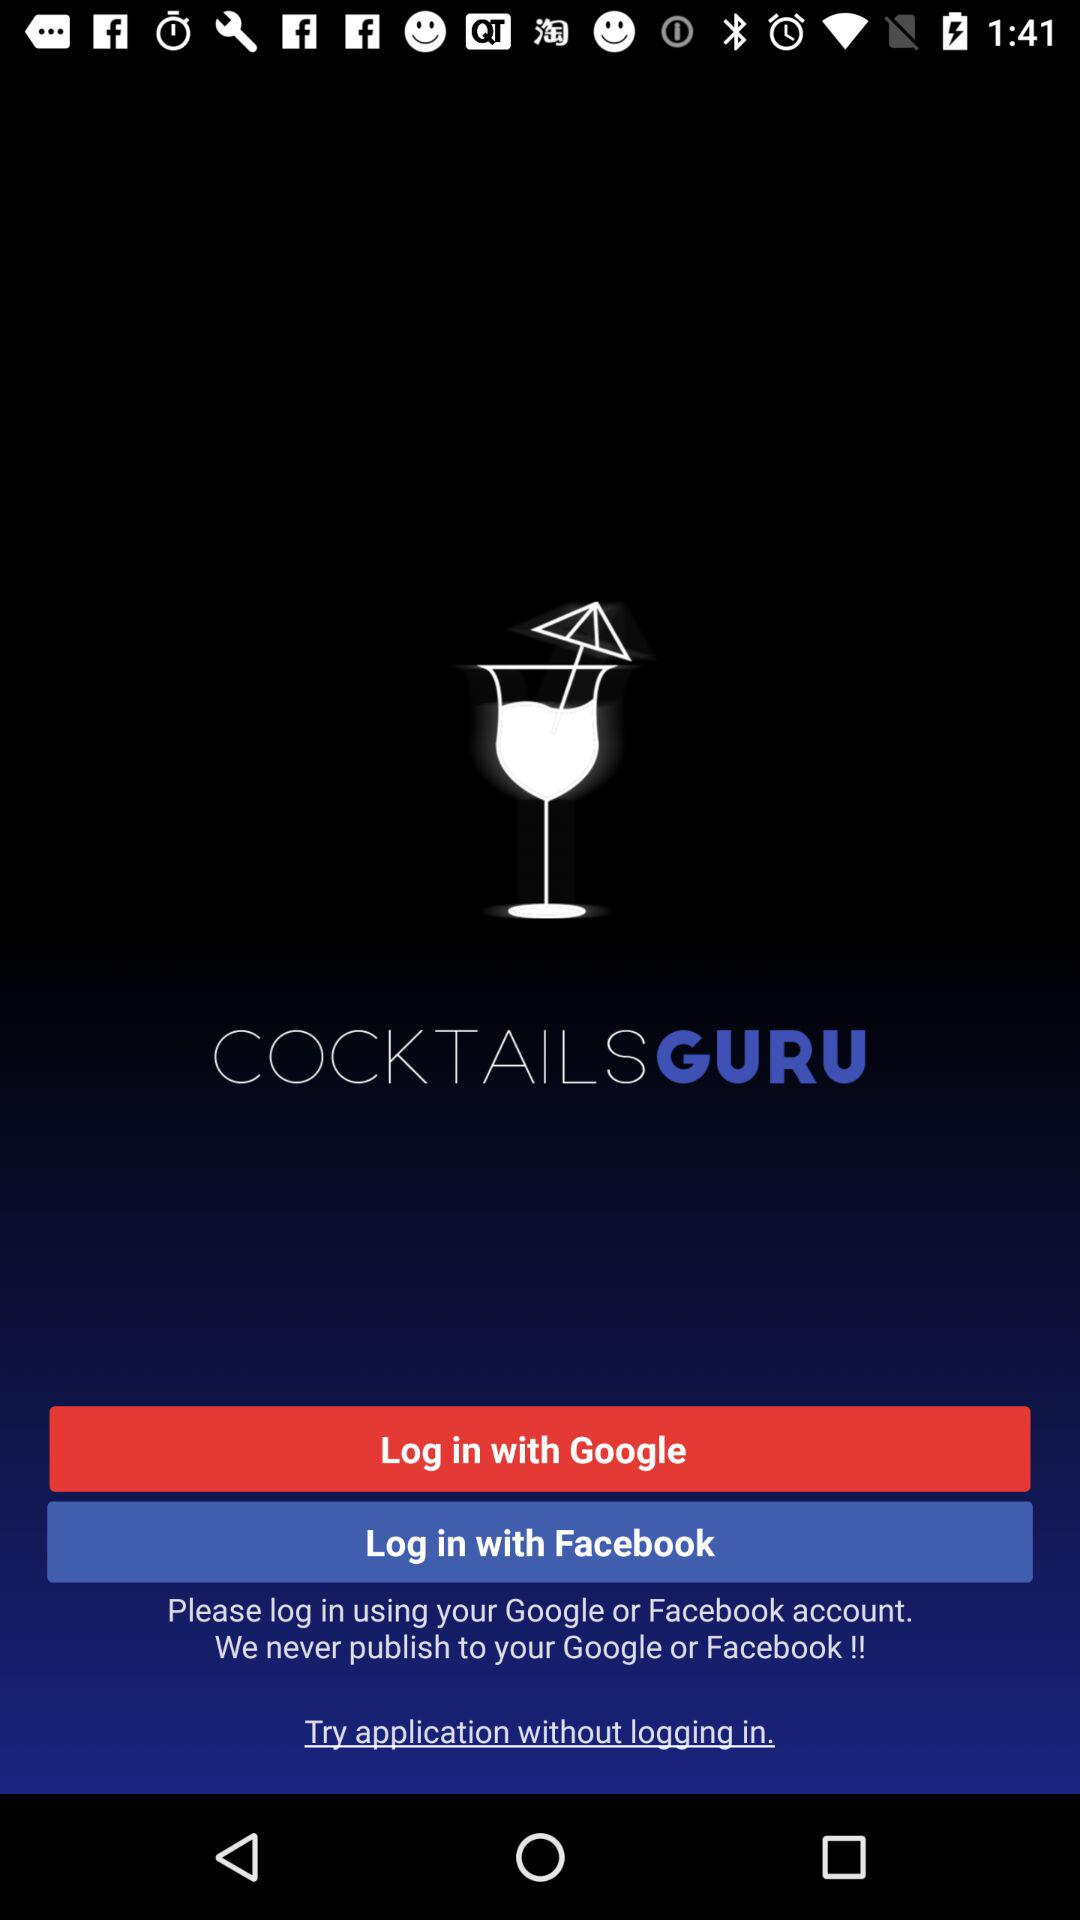What are the different options for logging in? The different options for logging in are "Google" and "Facebook". 